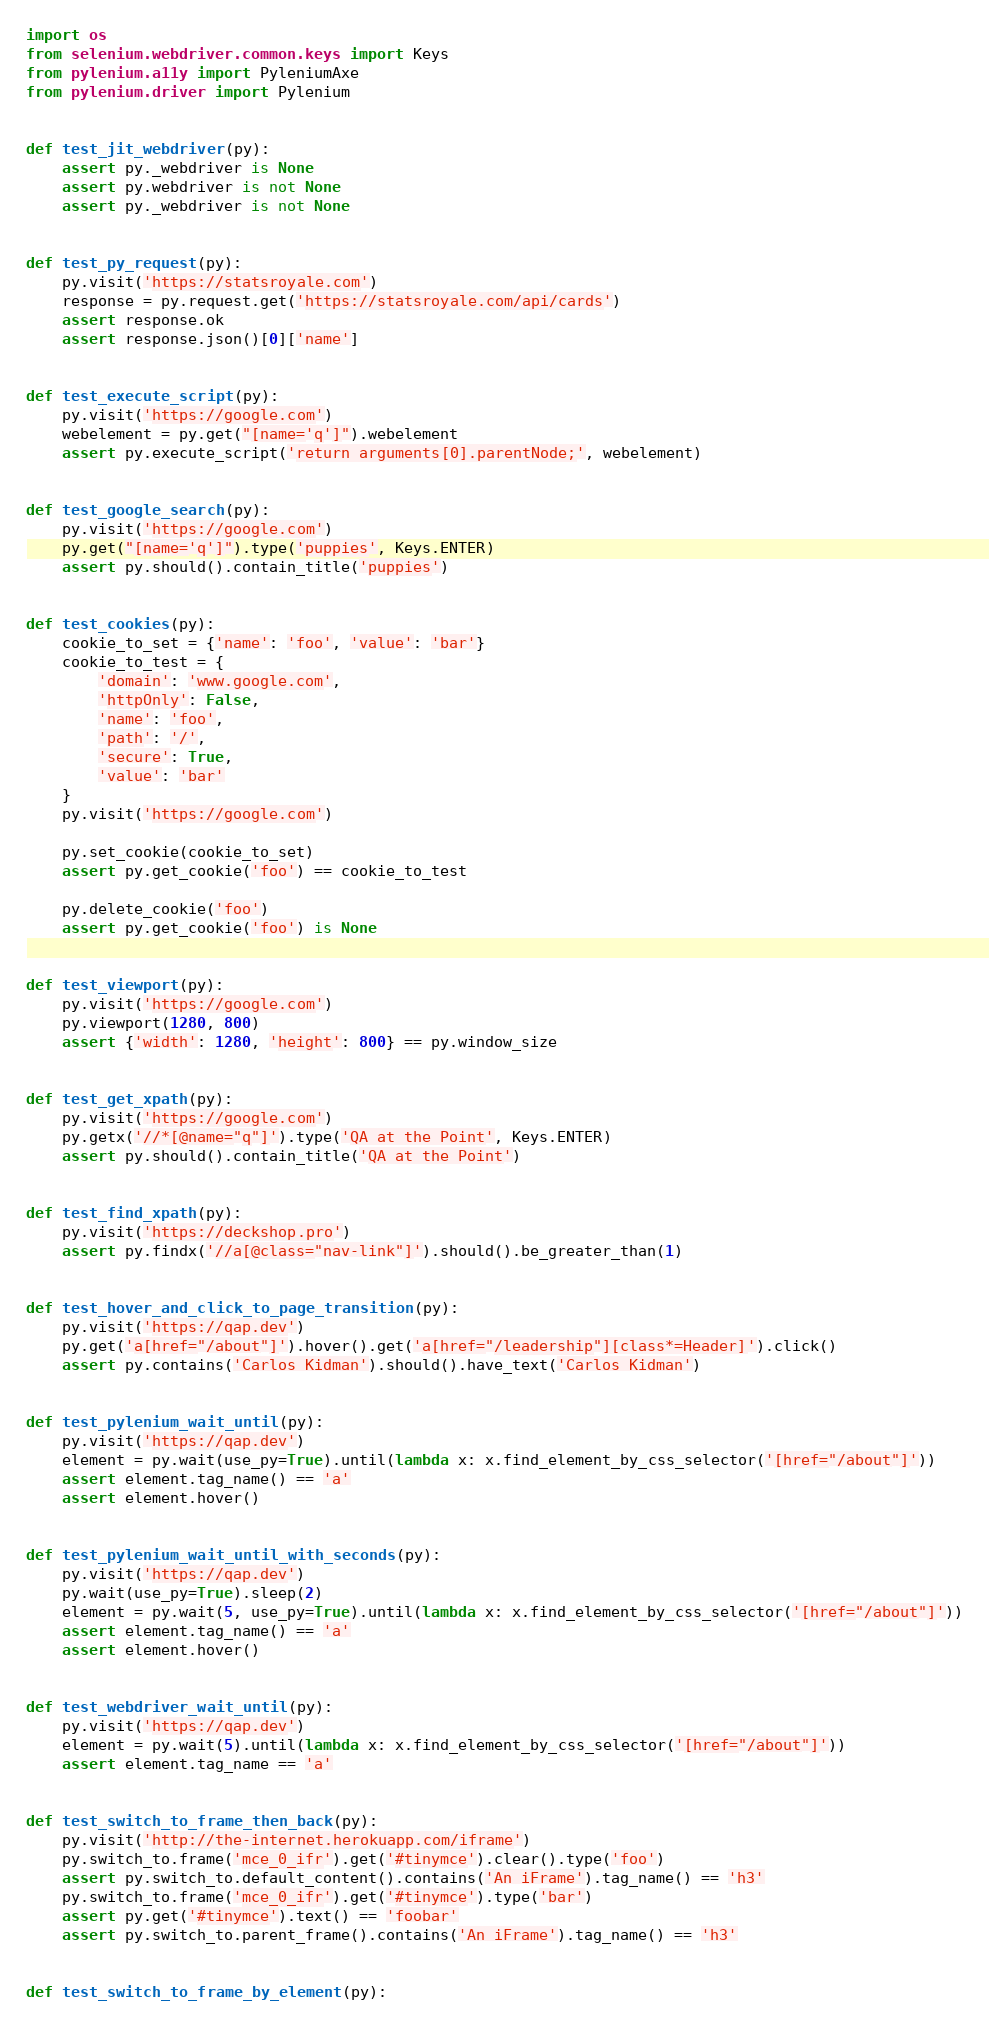Convert code to text. <code><loc_0><loc_0><loc_500><loc_500><_Python_>import os
from selenium.webdriver.common.keys import Keys
from pylenium.a11y import PyleniumAxe
from pylenium.driver import Pylenium


def test_jit_webdriver(py):
    assert py._webdriver is None
    assert py.webdriver is not None
    assert py._webdriver is not None


def test_py_request(py):
    py.visit('https://statsroyale.com')
    response = py.request.get('https://statsroyale.com/api/cards')
    assert response.ok
    assert response.json()[0]['name']


def test_execute_script(py):
    py.visit('https://google.com')
    webelement = py.get("[name='q']").webelement
    assert py.execute_script('return arguments[0].parentNode;', webelement)


def test_google_search(py):
    py.visit('https://google.com')
    py.get("[name='q']").type('puppies', Keys.ENTER)
    assert py.should().contain_title('puppies')


def test_cookies(py):
    cookie_to_set = {'name': 'foo', 'value': 'bar'}
    cookie_to_test = {
        'domain': 'www.google.com',
        'httpOnly': False,
        'name': 'foo',
        'path': '/',
        'secure': True,
        'value': 'bar'
    }
    py.visit('https://google.com')

    py.set_cookie(cookie_to_set)
    assert py.get_cookie('foo') == cookie_to_test

    py.delete_cookie('foo')
    assert py.get_cookie('foo') is None


def test_viewport(py):
    py.visit('https://google.com')
    py.viewport(1280, 800)
    assert {'width': 1280, 'height': 800} == py.window_size


def test_get_xpath(py):
    py.visit('https://google.com')
    py.getx('//*[@name="q"]').type('QA at the Point', Keys.ENTER)
    assert py.should().contain_title('QA at the Point')


def test_find_xpath(py):
    py.visit('https://deckshop.pro')
    assert py.findx('//a[@class="nav-link"]').should().be_greater_than(1)


def test_hover_and_click_to_page_transition(py):
    py.visit('https://qap.dev')
    py.get('a[href="/about"]').hover().get('a[href="/leadership"][class*=Header]').click()
    assert py.contains('Carlos Kidman').should().have_text('Carlos Kidman')


def test_pylenium_wait_until(py):
    py.visit('https://qap.dev')
    element = py.wait(use_py=True).until(lambda x: x.find_element_by_css_selector('[href="/about"]'))
    assert element.tag_name() == 'a'
    assert element.hover()


def test_pylenium_wait_until_with_seconds(py):
    py.visit('https://qap.dev')
    py.wait(use_py=True).sleep(2)
    element = py.wait(5, use_py=True).until(lambda x: x.find_element_by_css_selector('[href="/about"]'))
    assert element.tag_name() == 'a'
    assert element.hover()


def test_webdriver_wait_until(py):
    py.visit('https://qap.dev')
    element = py.wait(5).until(lambda x: x.find_element_by_css_selector('[href="/about"]'))
    assert element.tag_name == 'a'


def test_switch_to_frame_then_back(py):
    py.visit('http://the-internet.herokuapp.com/iframe')
    py.switch_to.frame('mce_0_ifr').get('#tinymce').clear().type('foo')
    assert py.switch_to.default_content().contains('An iFrame').tag_name() == 'h3'
    py.switch_to.frame('mce_0_ifr').get('#tinymce').type('bar')
    assert py.get('#tinymce').text() == 'foobar'
    assert py.switch_to.parent_frame().contains('An iFrame').tag_name() == 'h3'


def test_switch_to_frame_by_element(py):</code> 